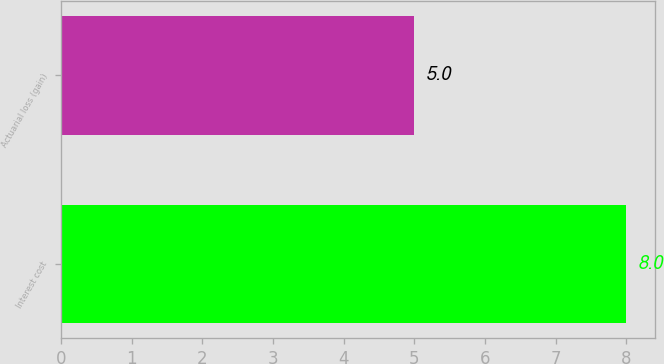Convert chart to OTSL. <chart><loc_0><loc_0><loc_500><loc_500><bar_chart><fcel>Interest cost<fcel>Actuarial loss (gain)<nl><fcel>8<fcel>5<nl></chart> 